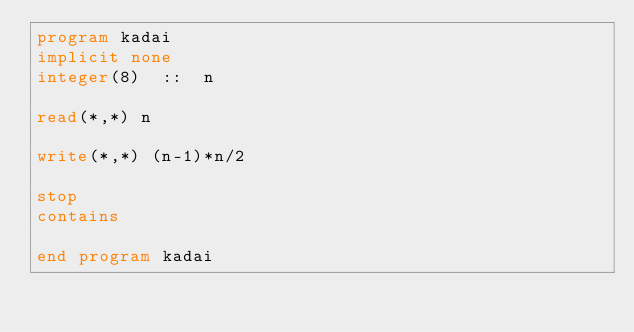<code> <loc_0><loc_0><loc_500><loc_500><_FORTRAN_>program kadai
implicit none
integer(8)  ::  n

read(*,*) n

write(*,*) (n-1)*n/2

stop
contains

end program kadai</code> 